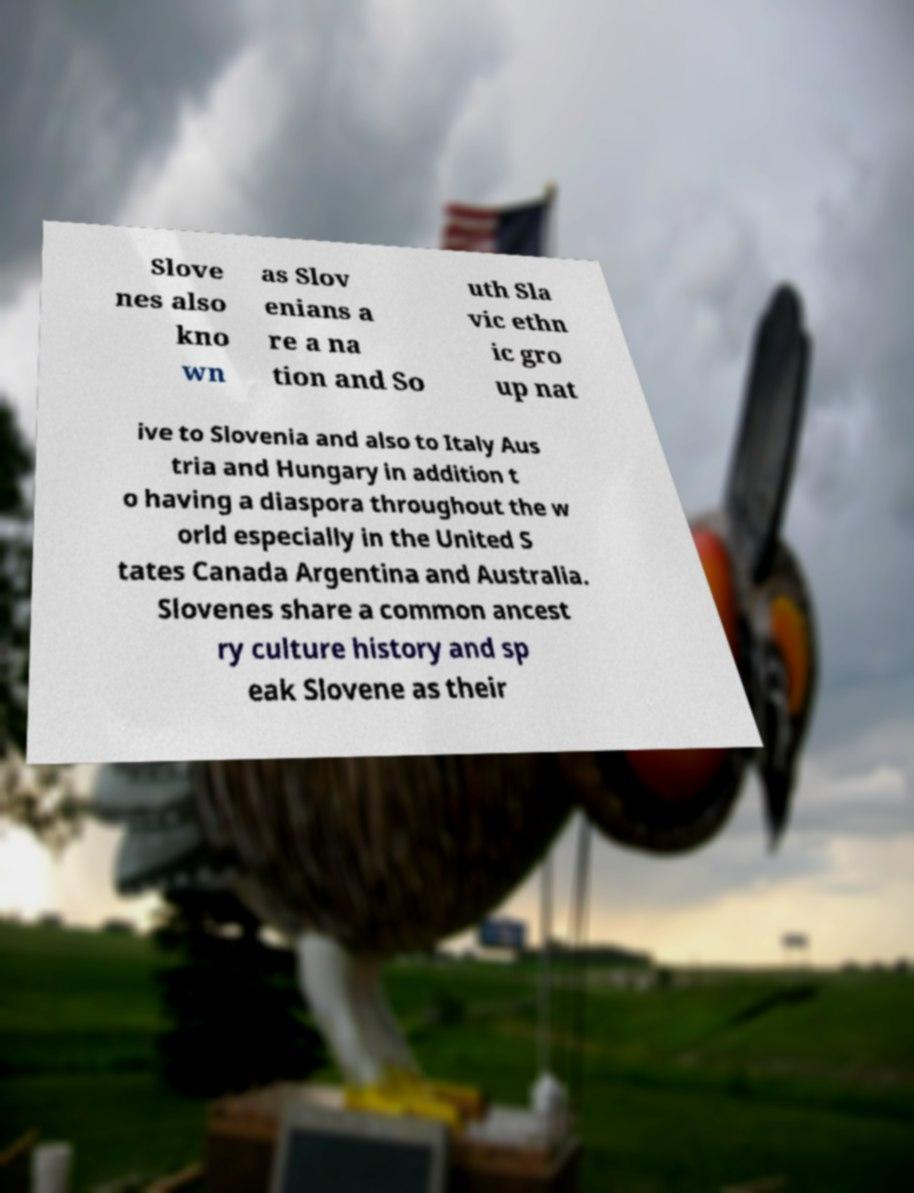Could you extract and type out the text from this image? Slove nes also kno wn as Slov enians a re a na tion and So uth Sla vic ethn ic gro up nat ive to Slovenia and also to Italy Aus tria and Hungary in addition t o having a diaspora throughout the w orld especially in the United S tates Canada Argentina and Australia. Slovenes share a common ancest ry culture history and sp eak Slovene as their 